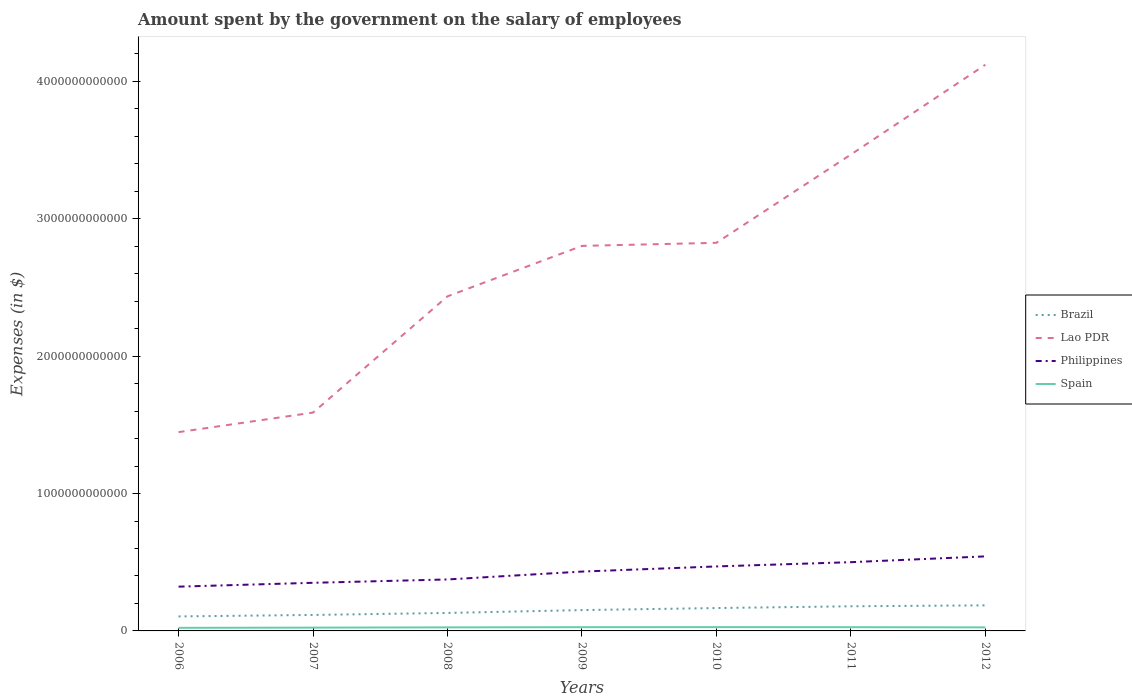How many different coloured lines are there?
Your answer should be very brief. 4. Across all years, what is the maximum amount spent on the salary of employees by the government in Brazil?
Keep it short and to the point. 1.05e+11. In which year was the amount spent on the salary of employees by the government in Spain maximum?
Offer a very short reply. 2006. What is the total amount spent on the salary of employees by the government in Spain in the graph?
Provide a short and direct response. 1.39e+09. What is the difference between the highest and the second highest amount spent on the salary of employees by the government in Brazil?
Keep it short and to the point. 8.06e+1. What is the difference between the highest and the lowest amount spent on the salary of employees by the government in Philippines?
Your response must be concise. 4. Is the amount spent on the salary of employees by the government in Brazil strictly greater than the amount spent on the salary of employees by the government in Spain over the years?
Ensure brevity in your answer.  No. What is the difference between two consecutive major ticks on the Y-axis?
Your answer should be very brief. 1.00e+12. Are the values on the major ticks of Y-axis written in scientific E-notation?
Offer a terse response. No. Where does the legend appear in the graph?
Give a very brief answer. Center right. How are the legend labels stacked?
Provide a succinct answer. Vertical. What is the title of the graph?
Keep it short and to the point. Amount spent by the government on the salary of employees. What is the label or title of the Y-axis?
Your answer should be compact. Expenses (in $). What is the Expenses (in $) of Brazil in 2006?
Your answer should be very brief. 1.05e+11. What is the Expenses (in $) of Lao PDR in 2006?
Offer a very short reply. 1.45e+12. What is the Expenses (in $) of Philippines in 2006?
Keep it short and to the point. 3.22e+11. What is the Expenses (in $) of Spain in 2006?
Your response must be concise. 2.25e+1. What is the Expenses (in $) of Brazil in 2007?
Your answer should be very brief. 1.16e+11. What is the Expenses (in $) of Lao PDR in 2007?
Make the answer very short. 1.59e+12. What is the Expenses (in $) in Philippines in 2007?
Make the answer very short. 3.50e+11. What is the Expenses (in $) in Spain in 2007?
Offer a very short reply. 2.40e+1. What is the Expenses (in $) in Brazil in 2008?
Offer a very short reply. 1.31e+11. What is the Expenses (in $) in Lao PDR in 2008?
Keep it short and to the point. 2.44e+12. What is the Expenses (in $) in Philippines in 2008?
Provide a succinct answer. 3.75e+11. What is the Expenses (in $) of Spain in 2008?
Your answer should be compact. 2.58e+1. What is the Expenses (in $) of Brazil in 2009?
Your answer should be very brief. 1.52e+11. What is the Expenses (in $) of Lao PDR in 2009?
Make the answer very short. 2.80e+12. What is the Expenses (in $) in Philippines in 2009?
Your answer should be very brief. 4.32e+11. What is the Expenses (in $) in Spain in 2009?
Keep it short and to the point. 2.71e+1. What is the Expenses (in $) in Brazil in 2010?
Offer a terse response. 1.66e+11. What is the Expenses (in $) of Lao PDR in 2010?
Your response must be concise. 2.83e+12. What is the Expenses (in $) in Philippines in 2010?
Offer a terse response. 4.69e+11. What is the Expenses (in $) of Spain in 2010?
Give a very brief answer. 2.76e+1. What is the Expenses (in $) of Brazil in 2011?
Offer a terse response. 1.79e+11. What is the Expenses (in $) of Lao PDR in 2011?
Provide a short and direct response. 3.47e+12. What is the Expenses (in $) in Philippines in 2011?
Ensure brevity in your answer.  5.00e+11. What is the Expenses (in $) of Spain in 2011?
Your answer should be compact. 2.71e+1. What is the Expenses (in $) in Brazil in 2012?
Your answer should be very brief. 1.86e+11. What is the Expenses (in $) of Lao PDR in 2012?
Ensure brevity in your answer.  4.12e+12. What is the Expenses (in $) of Philippines in 2012?
Your response must be concise. 5.43e+11. What is the Expenses (in $) of Spain in 2012?
Your answer should be compact. 2.58e+1. Across all years, what is the maximum Expenses (in $) of Brazil?
Your response must be concise. 1.86e+11. Across all years, what is the maximum Expenses (in $) in Lao PDR?
Your response must be concise. 4.12e+12. Across all years, what is the maximum Expenses (in $) in Philippines?
Ensure brevity in your answer.  5.43e+11. Across all years, what is the maximum Expenses (in $) in Spain?
Keep it short and to the point. 2.76e+1. Across all years, what is the minimum Expenses (in $) of Brazil?
Your answer should be compact. 1.05e+11. Across all years, what is the minimum Expenses (in $) of Lao PDR?
Offer a very short reply. 1.45e+12. Across all years, what is the minimum Expenses (in $) of Philippines?
Your response must be concise. 3.22e+11. Across all years, what is the minimum Expenses (in $) of Spain?
Your answer should be very brief. 2.25e+1. What is the total Expenses (in $) in Brazil in the graph?
Your answer should be compact. 1.04e+12. What is the total Expenses (in $) of Lao PDR in the graph?
Your answer should be very brief. 1.87e+13. What is the total Expenses (in $) of Philippines in the graph?
Provide a succinct answer. 2.99e+12. What is the total Expenses (in $) of Spain in the graph?
Make the answer very short. 1.80e+11. What is the difference between the Expenses (in $) in Brazil in 2006 and that in 2007?
Give a very brief answer. -1.09e+1. What is the difference between the Expenses (in $) of Lao PDR in 2006 and that in 2007?
Your answer should be very brief. -1.42e+11. What is the difference between the Expenses (in $) in Philippines in 2006 and that in 2007?
Provide a short and direct response. -2.80e+1. What is the difference between the Expenses (in $) in Spain in 2006 and that in 2007?
Ensure brevity in your answer.  -1.55e+09. What is the difference between the Expenses (in $) of Brazil in 2006 and that in 2008?
Provide a succinct answer. -2.53e+1. What is the difference between the Expenses (in $) of Lao PDR in 2006 and that in 2008?
Provide a short and direct response. -9.88e+11. What is the difference between the Expenses (in $) in Philippines in 2006 and that in 2008?
Provide a succinct answer. -5.24e+1. What is the difference between the Expenses (in $) of Spain in 2006 and that in 2008?
Offer a terse response. -3.36e+09. What is the difference between the Expenses (in $) of Brazil in 2006 and that in 2009?
Make the answer very short. -4.62e+1. What is the difference between the Expenses (in $) in Lao PDR in 2006 and that in 2009?
Offer a very short reply. -1.36e+12. What is the difference between the Expenses (in $) in Philippines in 2006 and that in 2009?
Offer a very short reply. -1.10e+11. What is the difference between the Expenses (in $) in Spain in 2006 and that in 2009?
Keep it short and to the point. -4.68e+09. What is the difference between the Expenses (in $) in Brazil in 2006 and that in 2010?
Provide a short and direct response. -6.10e+1. What is the difference between the Expenses (in $) in Lao PDR in 2006 and that in 2010?
Offer a very short reply. -1.38e+12. What is the difference between the Expenses (in $) in Philippines in 2006 and that in 2010?
Give a very brief answer. -1.47e+11. What is the difference between the Expenses (in $) in Spain in 2006 and that in 2010?
Provide a short and direct response. -5.13e+09. What is the difference between the Expenses (in $) in Brazil in 2006 and that in 2011?
Your answer should be very brief. -7.38e+1. What is the difference between the Expenses (in $) of Lao PDR in 2006 and that in 2011?
Your response must be concise. -2.02e+12. What is the difference between the Expenses (in $) of Philippines in 2006 and that in 2011?
Keep it short and to the point. -1.78e+11. What is the difference between the Expenses (in $) in Spain in 2006 and that in 2011?
Offer a very short reply. -4.67e+09. What is the difference between the Expenses (in $) of Brazil in 2006 and that in 2012?
Offer a very short reply. -8.06e+1. What is the difference between the Expenses (in $) of Lao PDR in 2006 and that in 2012?
Give a very brief answer. -2.67e+12. What is the difference between the Expenses (in $) of Philippines in 2006 and that in 2012?
Ensure brevity in your answer.  -2.20e+11. What is the difference between the Expenses (in $) in Spain in 2006 and that in 2012?
Make the answer very short. -3.29e+09. What is the difference between the Expenses (in $) of Brazil in 2007 and that in 2008?
Make the answer very short. -1.45e+1. What is the difference between the Expenses (in $) of Lao PDR in 2007 and that in 2008?
Provide a short and direct response. -8.46e+11. What is the difference between the Expenses (in $) of Philippines in 2007 and that in 2008?
Ensure brevity in your answer.  -2.44e+1. What is the difference between the Expenses (in $) in Spain in 2007 and that in 2008?
Ensure brevity in your answer.  -1.80e+09. What is the difference between the Expenses (in $) in Brazil in 2007 and that in 2009?
Your answer should be very brief. -3.53e+1. What is the difference between the Expenses (in $) of Lao PDR in 2007 and that in 2009?
Provide a succinct answer. -1.21e+12. What is the difference between the Expenses (in $) in Philippines in 2007 and that in 2009?
Provide a succinct answer. -8.17e+1. What is the difference between the Expenses (in $) of Spain in 2007 and that in 2009?
Offer a very short reply. -3.12e+09. What is the difference between the Expenses (in $) in Brazil in 2007 and that in 2010?
Ensure brevity in your answer.  -5.01e+1. What is the difference between the Expenses (in $) of Lao PDR in 2007 and that in 2010?
Your response must be concise. -1.24e+12. What is the difference between the Expenses (in $) in Philippines in 2007 and that in 2010?
Your answer should be very brief. -1.19e+11. What is the difference between the Expenses (in $) of Spain in 2007 and that in 2010?
Provide a short and direct response. -3.58e+09. What is the difference between the Expenses (in $) of Brazil in 2007 and that in 2011?
Your answer should be compact. -6.29e+1. What is the difference between the Expenses (in $) of Lao PDR in 2007 and that in 2011?
Ensure brevity in your answer.  -1.88e+12. What is the difference between the Expenses (in $) in Philippines in 2007 and that in 2011?
Ensure brevity in your answer.  -1.50e+11. What is the difference between the Expenses (in $) in Spain in 2007 and that in 2011?
Your answer should be compact. -3.12e+09. What is the difference between the Expenses (in $) in Brazil in 2007 and that in 2012?
Keep it short and to the point. -6.97e+1. What is the difference between the Expenses (in $) in Lao PDR in 2007 and that in 2012?
Provide a succinct answer. -2.53e+12. What is the difference between the Expenses (in $) in Philippines in 2007 and that in 2012?
Your answer should be very brief. -1.92e+11. What is the difference between the Expenses (in $) in Spain in 2007 and that in 2012?
Ensure brevity in your answer.  -1.74e+09. What is the difference between the Expenses (in $) in Brazil in 2008 and that in 2009?
Provide a succinct answer. -2.08e+1. What is the difference between the Expenses (in $) in Lao PDR in 2008 and that in 2009?
Make the answer very short. -3.67e+11. What is the difference between the Expenses (in $) of Philippines in 2008 and that in 2009?
Provide a succinct answer. -5.74e+1. What is the difference between the Expenses (in $) in Spain in 2008 and that in 2009?
Keep it short and to the point. -1.32e+09. What is the difference between the Expenses (in $) in Brazil in 2008 and that in 2010?
Ensure brevity in your answer.  -3.57e+1. What is the difference between the Expenses (in $) in Lao PDR in 2008 and that in 2010?
Provide a succinct answer. -3.90e+11. What is the difference between the Expenses (in $) of Philippines in 2008 and that in 2010?
Your answer should be compact. -9.47e+1. What is the difference between the Expenses (in $) in Spain in 2008 and that in 2010?
Your answer should be very brief. -1.78e+09. What is the difference between the Expenses (in $) in Brazil in 2008 and that in 2011?
Ensure brevity in your answer.  -4.84e+1. What is the difference between the Expenses (in $) in Lao PDR in 2008 and that in 2011?
Give a very brief answer. -1.03e+12. What is the difference between the Expenses (in $) of Philippines in 2008 and that in 2011?
Ensure brevity in your answer.  -1.26e+11. What is the difference between the Expenses (in $) of Spain in 2008 and that in 2011?
Your answer should be compact. -1.32e+09. What is the difference between the Expenses (in $) in Brazil in 2008 and that in 2012?
Your answer should be compact. -5.53e+1. What is the difference between the Expenses (in $) of Lao PDR in 2008 and that in 2012?
Offer a terse response. -1.69e+12. What is the difference between the Expenses (in $) of Philippines in 2008 and that in 2012?
Keep it short and to the point. -1.68e+11. What is the difference between the Expenses (in $) in Spain in 2008 and that in 2012?
Your answer should be very brief. 6.30e+07. What is the difference between the Expenses (in $) of Brazil in 2009 and that in 2010?
Provide a short and direct response. -1.48e+1. What is the difference between the Expenses (in $) of Lao PDR in 2009 and that in 2010?
Make the answer very short. -2.24e+1. What is the difference between the Expenses (in $) in Philippines in 2009 and that in 2010?
Make the answer very short. -3.74e+1. What is the difference between the Expenses (in $) in Spain in 2009 and that in 2010?
Make the answer very short. -4.54e+08. What is the difference between the Expenses (in $) in Brazil in 2009 and that in 2011?
Give a very brief answer. -2.76e+1. What is the difference between the Expenses (in $) of Lao PDR in 2009 and that in 2011?
Your answer should be very brief. -6.65e+11. What is the difference between the Expenses (in $) of Philippines in 2009 and that in 2011?
Offer a very short reply. -6.84e+1. What is the difference between the Expenses (in $) of Spain in 2009 and that in 2011?
Make the answer very short. 9.00e+06. What is the difference between the Expenses (in $) of Brazil in 2009 and that in 2012?
Keep it short and to the point. -3.44e+1. What is the difference between the Expenses (in $) in Lao PDR in 2009 and that in 2012?
Your response must be concise. -1.32e+12. What is the difference between the Expenses (in $) of Philippines in 2009 and that in 2012?
Keep it short and to the point. -1.11e+11. What is the difference between the Expenses (in $) in Spain in 2009 and that in 2012?
Make the answer very short. 1.39e+09. What is the difference between the Expenses (in $) of Brazil in 2010 and that in 2011?
Provide a succinct answer. -1.28e+1. What is the difference between the Expenses (in $) in Lao PDR in 2010 and that in 2011?
Ensure brevity in your answer.  -6.43e+11. What is the difference between the Expenses (in $) in Philippines in 2010 and that in 2011?
Provide a short and direct response. -3.10e+1. What is the difference between the Expenses (in $) in Spain in 2010 and that in 2011?
Your response must be concise. 4.63e+08. What is the difference between the Expenses (in $) of Brazil in 2010 and that in 2012?
Your answer should be compact. -1.96e+1. What is the difference between the Expenses (in $) of Lao PDR in 2010 and that in 2012?
Ensure brevity in your answer.  -1.30e+12. What is the difference between the Expenses (in $) in Philippines in 2010 and that in 2012?
Make the answer very short. -7.32e+1. What is the difference between the Expenses (in $) in Spain in 2010 and that in 2012?
Your answer should be compact. 1.84e+09. What is the difference between the Expenses (in $) in Brazil in 2011 and that in 2012?
Provide a succinct answer. -6.82e+09. What is the difference between the Expenses (in $) of Lao PDR in 2011 and that in 2012?
Provide a short and direct response. -6.54e+11. What is the difference between the Expenses (in $) of Philippines in 2011 and that in 2012?
Your response must be concise. -4.22e+1. What is the difference between the Expenses (in $) of Spain in 2011 and that in 2012?
Give a very brief answer. 1.38e+09. What is the difference between the Expenses (in $) in Brazil in 2006 and the Expenses (in $) in Lao PDR in 2007?
Your answer should be compact. -1.48e+12. What is the difference between the Expenses (in $) of Brazil in 2006 and the Expenses (in $) of Philippines in 2007?
Your answer should be compact. -2.45e+11. What is the difference between the Expenses (in $) of Brazil in 2006 and the Expenses (in $) of Spain in 2007?
Keep it short and to the point. 8.15e+1. What is the difference between the Expenses (in $) of Lao PDR in 2006 and the Expenses (in $) of Philippines in 2007?
Your answer should be compact. 1.10e+12. What is the difference between the Expenses (in $) in Lao PDR in 2006 and the Expenses (in $) in Spain in 2007?
Make the answer very short. 1.42e+12. What is the difference between the Expenses (in $) in Philippines in 2006 and the Expenses (in $) in Spain in 2007?
Provide a short and direct response. 2.98e+11. What is the difference between the Expenses (in $) in Brazil in 2006 and the Expenses (in $) in Lao PDR in 2008?
Your answer should be compact. -2.33e+12. What is the difference between the Expenses (in $) in Brazil in 2006 and the Expenses (in $) in Philippines in 2008?
Ensure brevity in your answer.  -2.69e+11. What is the difference between the Expenses (in $) in Brazil in 2006 and the Expenses (in $) in Spain in 2008?
Keep it short and to the point. 7.97e+1. What is the difference between the Expenses (in $) of Lao PDR in 2006 and the Expenses (in $) of Philippines in 2008?
Make the answer very short. 1.07e+12. What is the difference between the Expenses (in $) in Lao PDR in 2006 and the Expenses (in $) in Spain in 2008?
Your answer should be compact. 1.42e+12. What is the difference between the Expenses (in $) in Philippines in 2006 and the Expenses (in $) in Spain in 2008?
Ensure brevity in your answer.  2.96e+11. What is the difference between the Expenses (in $) of Brazil in 2006 and the Expenses (in $) of Lao PDR in 2009?
Keep it short and to the point. -2.70e+12. What is the difference between the Expenses (in $) in Brazil in 2006 and the Expenses (in $) in Philippines in 2009?
Your response must be concise. -3.27e+11. What is the difference between the Expenses (in $) in Brazil in 2006 and the Expenses (in $) in Spain in 2009?
Provide a succinct answer. 7.83e+1. What is the difference between the Expenses (in $) in Lao PDR in 2006 and the Expenses (in $) in Philippines in 2009?
Ensure brevity in your answer.  1.02e+12. What is the difference between the Expenses (in $) of Lao PDR in 2006 and the Expenses (in $) of Spain in 2009?
Give a very brief answer. 1.42e+12. What is the difference between the Expenses (in $) in Philippines in 2006 and the Expenses (in $) in Spain in 2009?
Your response must be concise. 2.95e+11. What is the difference between the Expenses (in $) of Brazil in 2006 and the Expenses (in $) of Lao PDR in 2010?
Provide a succinct answer. -2.72e+12. What is the difference between the Expenses (in $) of Brazil in 2006 and the Expenses (in $) of Philippines in 2010?
Keep it short and to the point. -3.64e+11. What is the difference between the Expenses (in $) of Brazil in 2006 and the Expenses (in $) of Spain in 2010?
Offer a very short reply. 7.79e+1. What is the difference between the Expenses (in $) in Lao PDR in 2006 and the Expenses (in $) in Philippines in 2010?
Your answer should be compact. 9.78e+11. What is the difference between the Expenses (in $) of Lao PDR in 2006 and the Expenses (in $) of Spain in 2010?
Offer a terse response. 1.42e+12. What is the difference between the Expenses (in $) in Philippines in 2006 and the Expenses (in $) in Spain in 2010?
Your answer should be very brief. 2.95e+11. What is the difference between the Expenses (in $) of Brazil in 2006 and the Expenses (in $) of Lao PDR in 2011?
Your answer should be very brief. -3.36e+12. What is the difference between the Expenses (in $) of Brazil in 2006 and the Expenses (in $) of Philippines in 2011?
Offer a terse response. -3.95e+11. What is the difference between the Expenses (in $) in Brazil in 2006 and the Expenses (in $) in Spain in 2011?
Offer a very short reply. 7.84e+1. What is the difference between the Expenses (in $) of Lao PDR in 2006 and the Expenses (in $) of Philippines in 2011?
Ensure brevity in your answer.  9.47e+11. What is the difference between the Expenses (in $) of Lao PDR in 2006 and the Expenses (in $) of Spain in 2011?
Your response must be concise. 1.42e+12. What is the difference between the Expenses (in $) of Philippines in 2006 and the Expenses (in $) of Spain in 2011?
Your response must be concise. 2.95e+11. What is the difference between the Expenses (in $) of Brazil in 2006 and the Expenses (in $) of Lao PDR in 2012?
Keep it short and to the point. -4.02e+12. What is the difference between the Expenses (in $) in Brazil in 2006 and the Expenses (in $) in Philippines in 2012?
Keep it short and to the point. -4.37e+11. What is the difference between the Expenses (in $) in Brazil in 2006 and the Expenses (in $) in Spain in 2012?
Your answer should be very brief. 7.97e+1. What is the difference between the Expenses (in $) in Lao PDR in 2006 and the Expenses (in $) in Philippines in 2012?
Make the answer very short. 9.04e+11. What is the difference between the Expenses (in $) in Lao PDR in 2006 and the Expenses (in $) in Spain in 2012?
Offer a terse response. 1.42e+12. What is the difference between the Expenses (in $) of Philippines in 2006 and the Expenses (in $) of Spain in 2012?
Your answer should be compact. 2.97e+11. What is the difference between the Expenses (in $) in Brazil in 2007 and the Expenses (in $) in Lao PDR in 2008?
Offer a very short reply. -2.32e+12. What is the difference between the Expenses (in $) of Brazil in 2007 and the Expenses (in $) of Philippines in 2008?
Offer a very short reply. -2.58e+11. What is the difference between the Expenses (in $) in Brazil in 2007 and the Expenses (in $) in Spain in 2008?
Offer a terse response. 9.05e+1. What is the difference between the Expenses (in $) of Lao PDR in 2007 and the Expenses (in $) of Philippines in 2008?
Give a very brief answer. 1.21e+12. What is the difference between the Expenses (in $) in Lao PDR in 2007 and the Expenses (in $) in Spain in 2008?
Offer a terse response. 1.56e+12. What is the difference between the Expenses (in $) of Philippines in 2007 and the Expenses (in $) of Spain in 2008?
Give a very brief answer. 3.24e+11. What is the difference between the Expenses (in $) of Brazil in 2007 and the Expenses (in $) of Lao PDR in 2009?
Your response must be concise. -2.69e+12. What is the difference between the Expenses (in $) in Brazil in 2007 and the Expenses (in $) in Philippines in 2009?
Offer a very short reply. -3.16e+11. What is the difference between the Expenses (in $) of Brazil in 2007 and the Expenses (in $) of Spain in 2009?
Keep it short and to the point. 8.92e+1. What is the difference between the Expenses (in $) in Lao PDR in 2007 and the Expenses (in $) in Philippines in 2009?
Ensure brevity in your answer.  1.16e+12. What is the difference between the Expenses (in $) of Lao PDR in 2007 and the Expenses (in $) of Spain in 2009?
Offer a terse response. 1.56e+12. What is the difference between the Expenses (in $) in Philippines in 2007 and the Expenses (in $) in Spain in 2009?
Offer a terse response. 3.23e+11. What is the difference between the Expenses (in $) in Brazil in 2007 and the Expenses (in $) in Lao PDR in 2010?
Provide a short and direct response. -2.71e+12. What is the difference between the Expenses (in $) of Brazil in 2007 and the Expenses (in $) of Philippines in 2010?
Provide a succinct answer. -3.53e+11. What is the difference between the Expenses (in $) of Brazil in 2007 and the Expenses (in $) of Spain in 2010?
Your answer should be compact. 8.88e+1. What is the difference between the Expenses (in $) in Lao PDR in 2007 and the Expenses (in $) in Philippines in 2010?
Your response must be concise. 1.12e+12. What is the difference between the Expenses (in $) of Lao PDR in 2007 and the Expenses (in $) of Spain in 2010?
Your answer should be compact. 1.56e+12. What is the difference between the Expenses (in $) in Philippines in 2007 and the Expenses (in $) in Spain in 2010?
Offer a very short reply. 3.23e+11. What is the difference between the Expenses (in $) in Brazil in 2007 and the Expenses (in $) in Lao PDR in 2011?
Offer a terse response. -3.35e+12. What is the difference between the Expenses (in $) of Brazil in 2007 and the Expenses (in $) of Philippines in 2011?
Provide a succinct answer. -3.84e+11. What is the difference between the Expenses (in $) in Brazil in 2007 and the Expenses (in $) in Spain in 2011?
Provide a succinct answer. 8.92e+1. What is the difference between the Expenses (in $) in Lao PDR in 2007 and the Expenses (in $) in Philippines in 2011?
Keep it short and to the point. 1.09e+12. What is the difference between the Expenses (in $) in Lao PDR in 2007 and the Expenses (in $) in Spain in 2011?
Ensure brevity in your answer.  1.56e+12. What is the difference between the Expenses (in $) of Philippines in 2007 and the Expenses (in $) of Spain in 2011?
Offer a terse response. 3.23e+11. What is the difference between the Expenses (in $) in Brazil in 2007 and the Expenses (in $) in Lao PDR in 2012?
Provide a succinct answer. -4.01e+12. What is the difference between the Expenses (in $) in Brazil in 2007 and the Expenses (in $) in Philippines in 2012?
Your answer should be compact. -4.26e+11. What is the difference between the Expenses (in $) in Brazil in 2007 and the Expenses (in $) in Spain in 2012?
Offer a very short reply. 9.06e+1. What is the difference between the Expenses (in $) of Lao PDR in 2007 and the Expenses (in $) of Philippines in 2012?
Make the answer very short. 1.05e+12. What is the difference between the Expenses (in $) in Lao PDR in 2007 and the Expenses (in $) in Spain in 2012?
Your answer should be compact. 1.56e+12. What is the difference between the Expenses (in $) in Philippines in 2007 and the Expenses (in $) in Spain in 2012?
Your response must be concise. 3.25e+11. What is the difference between the Expenses (in $) of Brazil in 2008 and the Expenses (in $) of Lao PDR in 2009?
Your response must be concise. -2.67e+12. What is the difference between the Expenses (in $) of Brazil in 2008 and the Expenses (in $) of Philippines in 2009?
Provide a succinct answer. -3.01e+11. What is the difference between the Expenses (in $) in Brazil in 2008 and the Expenses (in $) in Spain in 2009?
Your answer should be compact. 1.04e+11. What is the difference between the Expenses (in $) of Lao PDR in 2008 and the Expenses (in $) of Philippines in 2009?
Give a very brief answer. 2.00e+12. What is the difference between the Expenses (in $) of Lao PDR in 2008 and the Expenses (in $) of Spain in 2009?
Keep it short and to the point. 2.41e+12. What is the difference between the Expenses (in $) of Philippines in 2008 and the Expenses (in $) of Spain in 2009?
Provide a short and direct response. 3.48e+11. What is the difference between the Expenses (in $) of Brazil in 2008 and the Expenses (in $) of Lao PDR in 2010?
Offer a very short reply. -2.69e+12. What is the difference between the Expenses (in $) in Brazil in 2008 and the Expenses (in $) in Philippines in 2010?
Keep it short and to the point. -3.39e+11. What is the difference between the Expenses (in $) of Brazil in 2008 and the Expenses (in $) of Spain in 2010?
Make the answer very short. 1.03e+11. What is the difference between the Expenses (in $) of Lao PDR in 2008 and the Expenses (in $) of Philippines in 2010?
Make the answer very short. 1.97e+12. What is the difference between the Expenses (in $) of Lao PDR in 2008 and the Expenses (in $) of Spain in 2010?
Your response must be concise. 2.41e+12. What is the difference between the Expenses (in $) of Philippines in 2008 and the Expenses (in $) of Spain in 2010?
Your answer should be compact. 3.47e+11. What is the difference between the Expenses (in $) of Brazil in 2008 and the Expenses (in $) of Lao PDR in 2011?
Provide a succinct answer. -3.34e+12. What is the difference between the Expenses (in $) in Brazil in 2008 and the Expenses (in $) in Philippines in 2011?
Give a very brief answer. -3.70e+11. What is the difference between the Expenses (in $) in Brazil in 2008 and the Expenses (in $) in Spain in 2011?
Provide a short and direct response. 1.04e+11. What is the difference between the Expenses (in $) of Lao PDR in 2008 and the Expenses (in $) of Philippines in 2011?
Provide a succinct answer. 1.94e+12. What is the difference between the Expenses (in $) of Lao PDR in 2008 and the Expenses (in $) of Spain in 2011?
Provide a short and direct response. 2.41e+12. What is the difference between the Expenses (in $) in Philippines in 2008 and the Expenses (in $) in Spain in 2011?
Make the answer very short. 3.48e+11. What is the difference between the Expenses (in $) in Brazil in 2008 and the Expenses (in $) in Lao PDR in 2012?
Offer a very short reply. -3.99e+12. What is the difference between the Expenses (in $) of Brazil in 2008 and the Expenses (in $) of Philippines in 2012?
Keep it short and to the point. -4.12e+11. What is the difference between the Expenses (in $) in Brazil in 2008 and the Expenses (in $) in Spain in 2012?
Keep it short and to the point. 1.05e+11. What is the difference between the Expenses (in $) in Lao PDR in 2008 and the Expenses (in $) in Philippines in 2012?
Keep it short and to the point. 1.89e+12. What is the difference between the Expenses (in $) of Lao PDR in 2008 and the Expenses (in $) of Spain in 2012?
Provide a short and direct response. 2.41e+12. What is the difference between the Expenses (in $) of Philippines in 2008 and the Expenses (in $) of Spain in 2012?
Provide a succinct answer. 3.49e+11. What is the difference between the Expenses (in $) in Brazil in 2009 and the Expenses (in $) in Lao PDR in 2010?
Provide a succinct answer. -2.67e+12. What is the difference between the Expenses (in $) in Brazil in 2009 and the Expenses (in $) in Philippines in 2010?
Your answer should be very brief. -3.18e+11. What is the difference between the Expenses (in $) of Brazil in 2009 and the Expenses (in $) of Spain in 2010?
Keep it short and to the point. 1.24e+11. What is the difference between the Expenses (in $) of Lao PDR in 2009 and the Expenses (in $) of Philippines in 2010?
Provide a succinct answer. 2.33e+12. What is the difference between the Expenses (in $) in Lao PDR in 2009 and the Expenses (in $) in Spain in 2010?
Your response must be concise. 2.78e+12. What is the difference between the Expenses (in $) of Philippines in 2009 and the Expenses (in $) of Spain in 2010?
Offer a very short reply. 4.04e+11. What is the difference between the Expenses (in $) in Brazil in 2009 and the Expenses (in $) in Lao PDR in 2011?
Provide a succinct answer. -3.32e+12. What is the difference between the Expenses (in $) in Brazil in 2009 and the Expenses (in $) in Philippines in 2011?
Ensure brevity in your answer.  -3.49e+11. What is the difference between the Expenses (in $) of Brazil in 2009 and the Expenses (in $) of Spain in 2011?
Your response must be concise. 1.25e+11. What is the difference between the Expenses (in $) in Lao PDR in 2009 and the Expenses (in $) in Philippines in 2011?
Your response must be concise. 2.30e+12. What is the difference between the Expenses (in $) of Lao PDR in 2009 and the Expenses (in $) of Spain in 2011?
Provide a short and direct response. 2.78e+12. What is the difference between the Expenses (in $) in Philippines in 2009 and the Expenses (in $) in Spain in 2011?
Offer a very short reply. 4.05e+11. What is the difference between the Expenses (in $) in Brazil in 2009 and the Expenses (in $) in Lao PDR in 2012?
Your response must be concise. -3.97e+12. What is the difference between the Expenses (in $) of Brazil in 2009 and the Expenses (in $) of Philippines in 2012?
Your response must be concise. -3.91e+11. What is the difference between the Expenses (in $) of Brazil in 2009 and the Expenses (in $) of Spain in 2012?
Keep it short and to the point. 1.26e+11. What is the difference between the Expenses (in $) in Lao PDR in 2009 and the Expenses (in $) in Philippines in 2012?
Offer a terse response. 2.26e+12. What is the difference between the Expenses (in $) in Lao PDR in 2009 and the Expenses (in $) in Spain in 2012?
Your response must be concise. 2.78e+12. What is the difference between the Expenses (in $) of Philippines in 2009 and the Expenses (in $) of Spain in 2012?
Your answer should be compact. 4.06e+11. What is the difference between the Expenses (in $) in Brazil in 2010 and the Expenses (in $) in Lao PDR in 2011?
Offer a very short reply. -3.30e+12. What is the difference between the Expenses (in $) in Brazil in 2010 and the Expenses (in $) in Philippines in 2011?
Make the answer very short. -3.34e+11. What is the difference between the Expenses (in $) of Brazil in 2010 and the Expenses (in $) of Spain in 2011?
Your response must be concise. 1.39e+11. What is the difference between the Expenses (in $) of Lao PDR in 2010 and the Expenses (in $) of Philippines in 2011?
Offer a terse response. 2.32e+12. What is the difference between the Expenses (in $) in Lao PDR in 2010 and the Expenses (in $) in Spain in 2011?
Your answer should be compact. 2.80e+12. What is the difference between the Expenses (in $) in Philippines in 2010 and the Expenses (in $) in Spain in 2011?
Keep it short and to the point. 4.42e+11. What is the difference between the Expenses (in $) of Brazil in 2010 and the Expenses (in $) of Lao PDR in 2012?
Provide a succinct answer. -3.95e+12. What is the difference between the Expenses (in $) in Brazil in 2010 and the Expenses (in $) in Philippines in 2012?
Give a very brief answer. -3.76e+11. What is the difference between the Expenses (in $) in Brazil in 2010 and the Expenses (in $) in Spain in 2012?
Your response must be concise. 1.41e+11. What is the difference between the Expenses (in $) in Lao PDR in 2010 and the Expenses (in $) in Philippines in 2012?
Your answer should be compact. 2.28e+12. What is the difference between the Expenses (in $) of Lao PDR in 2010 and the Expenses (in $) of Spain in 2012?
Keep it short and to the point. 2.80e+12. What is the difference between the Expenses (in $) in Philippines in 2010 and the Expenses (in $) in Spain in 2012?
Your answer should be compact. 4.44e+11. What is the difference between the Expenses (in $) of Brazil in 2011 and the Expenses (in $) of Lao PDR in 2012?
Provide a short and direct response. -3.94e+12. What is the difference between the Expenses (in $) in Brazil in 2011 and the Expenses (in $) in Philippines in 2012?
Your answer should be compact. -3.63e+11. What is the difference between the Expenses (in $) of Brazil in 2011 and the Expenses (in $) of Spain in 2012?
Your response must be concise. 1.54e+11. What is the difference between the Expenses (in $) in Lao PDR in 2011 and the Expenses (in $) in Philippines in 2012?
Ensure brevity in your answer.  2.93e+12. What is the difference between the Expenses (in $) in Lao PDR in 2011 and the Expenses (in $) in Spain in 2012?
Provide a succinct answer. 3.44e+12. What is the difference between the Expenses (in $) in Philippines in 2011 and the Expenses (in $) in Spain in 2012?
Offer a very short reply. 4.75e+11. What is the average Expenses (in $) in Brazil per year?
Keep it short and to the point. 1.48e+11. What is the average Expenses (in $) of Lao PDR per year?
Offer a terse response. 2.67e+12. What is the average Expenses (in $) of Philippines per year?
Your answer should be very brief. 4.27e+11. What is the average Expenses (in $) in Spain per year?
Give a very brief answer. 2.57e+1. In the year 2006, what is the difference between the Expenses (in $) of Brazil and Expenses (in $) of Lao PDR?
Offer a terse response. -1.34e+12. In the year 2006, what is the difference between the Expenses (in $) in Brazil and Expenses (in $) in Philippines?
Provide a succinct answer. -2.17e+11. In the year 2006, what is the difference between the Expenses (in $) of Brazil and Expenses (in $) of Spain?
Your answer should be compact. 8.30e+1. In the year 2006, what is the difference between the Expenses (in $) in Lao PDR and Expenses (in $) in Philippines?
Your answer should be very brief. 1.12e+12. In the year 2006, what is the difference between the Expenses (in $) in Lao PDR and Expenses (in $) in Spain?
Keep it short and to the point. 1.42e+12. In the year 2006, what is the difference between the Expenses (in $) of Philippines and Expenses (in $) of Spain?
Keep it short and to the point. 3.00e+11. In the year 2007, what is the difference between the Expenses (in $) of Brazil and Expenses (in $) of Lao PDR?
Your answer should be compact. -1.47e+12. In the year 2007, what is the difference between the Expenses (in $) in Brazil and Expenses (in $) in Philippines?
Your answer should be compact. -2.34e+11. In the year 2007, what is the difference between the Expenses (in $) of Brazil and Expenses (in $) of Spain?
Give a very brief answer. 9.23e+1. In the year 2007, what is the difference between the Expenses (in $) of Lao PDR and Expenses (in $) of Philippines?
Make the answer very short. 1.24e+12. In the year 2007, what is the difference between the Expenses (in $) of Lao PDR and Expenses (in $) of Spain?
Offer a terse response. 1.57e+12. In the year 2007, what is the difference between the Expenses (in $) of Philippines and Expenses (in $) of Spain?
Ensure brevity in your answer.  3.26e+11. In the year 2008, what is the difference between the Expenses (in $) of Brazil and Expenses (in $) of Lao PDR?
Your answer should be compact. -2.30e+12. In the year 2008, what is the difference between the Expenses (in $) of Brazil and Expenses (in $) of Philippines?
Offer a terse response. -2.44e+11. In the year 2008, what is the difference between the Expenses (in $) of Brazil and Expenses (in $) of Spain?
Offer a very short reply. 1.05e+11. In the year 2008, what is the difference between the Expenses (in $) in Lao PDR and Expenses (in $) in Philippines?
Offer a very short reply. 2.06e+12. In the year 2008, what is the difference between the Expenses (in $) in Lao PDR and Expenses (in $) in Spain?
Give a very brief answer. 2.41e+12. In the year 2008, what is the difference between the Expenses (in $) of Philippines and Expenses (in $) of Spain?
Give a very brief answer. 3.49e+11. In the year 2009, what is the difference between the Expenses (in $) in Brazil and Expenses (in $) in Lao PDR?
Provide a succinct answer. -2.65e+12. In the year 2009, what is the difference between the Expenses (in $) in Brazil and Expenses (in $) in Philippines?
Provide a short and direct response. -2.80e+11. In the year 2009, what is the difference between the Expenses (in $) of Brazil and Expenses (in $) of Spain?
Your response must be concise. 1.25e+11. In the year 2009, what is the difference between the Expenses (in $) in Lao PDR and Expenses (in $) in Philippines?
Give a very brief answer. 2.37e+12. In the year 2009, what is the difference between the Expenses (in $) of Lao PDR and Expenses (in $) of Spain?
Give a very brief answer. 2.78e+12. In the year 2009, what is the difference between the Expenses (in $) of Philippines and Expenses (in $) of Spain?
Provide a short and direct response. 4.05e+11. In the year 2010, what is the difference between the Expenses (in $) in Brazil and Expenses (in $) in Lao PDR?
Give a very brief answer. -2.66e+12. In the year 2010, what is the difference between the Expenses (in $) in Brazil and Expenses (in $) in Philippines?
Provide a succinct answer. -3.03e+11. In the year 2010, what is the difference between the Expenses (in $) of Brazil and Expenses (in $) of Spain?
Ensure brevity in your answer.  1.39e+11. In the year 2010, what is the difference between the Expenses (in $) of Lao PDR and Expenses (in $) of Philippines?
Offer a very short reply. 2.36e+12. In the year 2010, what is the difference between the Expenses (in $) in Lao PDR and Expenses (in $) in Spain?
Ensure brevity in your answer.  2.80e+12. In the year 2010, what is the difference between the Expenses (in $) in Philippines and Expenses (in $) in Spain?
Your answer should be compact. 4.42e+11. In the year 2011, what is the difference between the Expenses (in $) in Brazil and Expenses (in $) in Lao PDR?
Give a very brief answer. -3.29e+12. In the year 2011, what is the difference between the Expenses (in $) of Brazil and Expenses (in $) of Philippines?
Offer a very short reply. -3.21e+11. In the year 2011, what is the difference between the Expenses (in $) of Brazil and Expenses (in $) of Spain?
Make the answer very short. 1.52e+11. In the year 2011, what is the difference between the Expenses (in $) in Lao PDR and Expenses (in $) in Philippines?
Ensure brevity in your answer.  2.97e+12. In the year 2011, what is the difference between the Expenses (in $) in Lao PDR and Expenses (in $) in Spain?
Offer a terse response. 3.44e+12. In the year 2011, what is the difference between the Expenses (in $) in Philippines and Expenses (in $) in Spain?
Keep it short and to the point. 4.73e+11. In the year 2012, what is the difference between the Expenses (in $) in Brazil and Expenses (in $) in Lao PDR?
Provide a short and direct response. -3.94e+12. In the year 2012, what is the difference between the Expenses (in $) of Brazil and Expenses (in $) of Philippines?
Provide a succinct answer. -3.57e+11. In the year 2012, what is the difference between the Expenses (in $) in Brazil and Expenses (in $) in Spain?
Make the answer very short. 1.60e+11. In the year 2012, what is the difference between the Expenses (in $) in Lao PDR and Expenses (in $) in Philippines?
Ensure brevity in your answer.  3.58e+12. In the year 2012, what is the difference between the Expenses (in $) of Lao PDR and Expenses (in $) of Spain?
Give a very brief answer. 4.10e+12. In the year 2012, what is the difference between the Expenses (in $) of Philippines and Expenses (in $) of Spain?
Offer a terse response. 5.17e+11. What is the ratio of the Expenses (in $) of Brazil in 2006 to that in 2007?
Make the answer very short. 0.91. What is the ratio of the Expenses (in $) in Lao PDR in 2006 to that in 2007?
Provide a short and direct response. 0.91. What is the ratio of the Expenses (in $) in Spain in 2006 to that in 2007?
Your answer should be very brief. 0.94. What is the ratio of the Expenses (in $) in Brazil in 2006 to that in 2008?
Offer a very short reply. 0.81. What is the ratio of the Expenses (in $) of Lao PDR in 2006 to that in 2008?
Your answer should be very brief. 0.59. What is the ratio of the Expenses (in $) in Philippines in 2006 to that in 2008?
Provide a short and direct response. 0.86. What is the ratio of the Expenses (in $) in Spain in 2006 to that in 2008?
Provide a succinct answer. 0.87. What is the ratio of the Expenses (in $) of Brazil in 2006 to that in 2009?
Provide a succinct answer. 0.7. What is the ratio of the Expenses (in $) in Lao PDR in 2006 to that in 2009?
Provide a short and direct response. 0.52. What is the ratio of the Expenses (in $) of Philippines in 2006 to that in 2009?
Your answer should be compact. 0.75. What is the ratio of the Expenses (in $) of Spain in 2006 to that in 2009?
Your response must be concise. 0.83. What is the ratio of the Expenses (in $) of Brazil in 2006 to that in 2010?
Give a very brief answer. 0.63. What is the ratio of the Expenses (in $) in Lao PDR in 2006 to that in 2010?
Ensure brevity in your answer.  0.51. What is the ratio of the Expenses (in $) in Philippines in 2006 to that in 2010?
Give a very brief answer. 0.69. What is the ratio of the Expenses (in $) in Spain in 2006 to that in 2010?
Your response must be concise. 0.81. What is the ratio of the Expenses (in $) of Brazil in 2006 to that in 2011?
Your answer should be very brief. 0.59. What is the ratio of the Expenses (in $) of Lao PDR in 2006 to that in 2011?
Provide a succinct answer. 0.42. What is the ratio of the Expenses (in $) of Philippines in 2006 to that in 2011?
Offer a very short reply. 0.64. What is the ratio of the Expenses (in $) of Spain in 2006 to that in 2011?
Your response must be concise. 0.83. What is the ratio of the Expenses (in $) in Brazil in 2006 to that in 2012?
Offer a very short reply. 0.57. What is the ratio of the Expenses (in $) in Lao PDR in 2006 to that in 2012?
Your answer should be very brief. 0.35. What is the ratio of the Expenses (in $) in Philippines in 2006 to that in 2012?
Make the answer very short. 0.59. What is the ratio of the Expenses (in $) of Spain in 2006 to that in 2012?
Your response must be concise. 0.87. What is the ratio of the Expenses (in $) in Brazil in 2007 to that in 2008?
Provide a succinct answer. 0.89. What is the ratio of the Expenses (in $) in Lao PDR in 2007 to that in 2008?
Ensure brevity in your answer.  0.65. What is the ratio of the Expenses (in $) of Philippines in 2007 to that in 2008?
Your answer should be very brief. 0.94. What is the ratio of the Expenses (in $) of Spain in 2007 to that in 2008?
Provide a short and direct response. 0.93. What is the ratio of the Expenses (in $) of Brazil in 2007 to that in 2009?
Provide a short and direct response. 0.77. What is the ratio of the Expenses (in $) of Lao PDR in 2007 to that in 2009?
Ensure brevity in your answer.  0.57. What is the ratio of the Expenses (in $) of Philippines in 2007 to that in 2009?
Offer a terse response. 0.81. What is the ratio of the Expenses (in $) of Spain in 2007 to that in 2009?
Offer a terse response. 0.88. What is the ratio of the Expenses (in $) of Brazil in 2007 to that in 2010?
Your answer should be very brief. 0.7. What is the ratio of the Expenses (in $) in Lao PDR in 2007 to that in 2010?
Provide a short and direct response. 0.56. What is the ratio of the Expenses (in $) in Philippines in 2007 to that in 2010?
Provide a short and direct response. 0.75. What is the ratio of the Expenses (in $) in Spain in 2007 to that in 2010?
Provide a short and direct response. 0.87. What is the ratio of the Expenses (in $) of Brazil in 2007 to that in 2011?
Ensure brevity in your answer.  0.65. What is the ratio of the Expenses (in $) in Lao PDR in 2007 to that in 2011?
Your answer should be very brief. 0.46. What is the ratio of the Expenses (in $) of Philippines in 2007 to that in 2011?
Keep it short and to the point. 0.7. What is the ratio of the Expenses (in $) of Spain in 2007 to that in 2011?
Your answer should be very brief. 0.89. What is the ratio of the Expenses (in $) in Brazil in 2007 to that in 2012?
Your answer should be very brief. 0.63. What is the ratio of the Expenses (in $) in Lao PDR in 2007 to that in 2012?
Your response must be concise. 0.39. What is the ratio of the Expenses (in $) in Philippines in 2007 to that in 2012?
Offer a very short reply. 0.65. What is the ratio of the Expenses (in $) of Spain in 2007 to that in 2012?
Your answer should be very brief. 0.93. What is the ratio of the Expenses (in $) in Brazil in 2008 to that in 2009?
Give a very brief answer. 0.86. What is the ratio of the Expenses (in $) in Lao PDR in 2008 to that in 2009?
Offer a very short reply. 0.87. What is the ratio of the Expenses (in $) of Philippines in 2008 to that in 2009?
Offer a very short reply. 0.87. What is the ratio of the Expenses (in $) of Spain in 2008 to that in 2009?
Offer a very short reply. 0.95. What is the ratio of the Expenses (in $) in Brazil in 2008 to that in 2010?
Your answer should be compact. 0.79. What is the ratio of the Expenses (in $) in Lao PDR in 2008 to that in 2010?
Provide a succinct answer. 0.86. What is the ratio of the Expenses (in $) in Philippines in 2008 to that in 2010?
Keep it short and to the point. 0.8. What is the ratio of the Expenses (in $) of Spain in 2008 to that in 2010?
Your answer should be compact. 0.94. What is the ratio of the Expenses (in $) of Brazil in 2008 to that in 2011?
Offer a very short reply. 0.73. What is the ratio of the Expenses (in $) in Lao PDR in 2008 to that in 2011?
Your answer should be compact. 0.7. What is the ratio of the Expenses (in $) of Philippines in 2008 to that in 2011?
Offer a very short reply. 0.75. What is the ratio of the Expenses (in $) of Spain in 2008 to that in 2011?
Keep it short and to the point. 0.95. What is the ratio of the Expenses (in $) in Brazil in 2008 to that in 2012?
Keep it short and to the point. 0.7. What is the ratio of the Expenses (in $) in Lao PDR in 2008 to that in 2012?
Offer a very short reply. 0.59. What is the ratio of the Expenses (in $) of Philippines in 2008 to that in 2012?
Provide a short and direct response. 0.69. What is the ratio of the Expenses (in $) of Spain in 2008 to that in 2012?
Offer a terse response. 1. What is the ratio of the Expenses (in $) in Brazil in 2009 to that in 2010?
Provide a short and direct response. 0.91. What is the ratio of the Expenses (in $) in Philippines in 2009 to that in 2010?
Your response must be concise. 0.92. What is the ratio of the Expenses (in $) of Spain in 2009 to that in 2010?
Your response must be concise. 0.98. What is the ratio of the Expenses (in $) in Brazil in 2009 to that in 2011?
Provide a short and direct response. 0.85. What is the ratio of the Expenses (in $) in Lao PDR in 2009 to that in 2011?
Your response must be concise. 0.81. What is the ratio of the Expenses (in $) in Philippines in 2009 to that in 2011?
Offer a terse response. 0.86. What is the ratio of the Expenses (in $) of Spain in 2009 to that in 2011?
Provide a succinct answer. 1. What is the ratio of the Expenses (in $) of Brazil in 2009 to that in 2012?
Offer a terse response. 0.81. What is the ratio of the Expenses (in $) in Lao PDR in 2009 to that in 2012?
Ensure brevity in your answer.  0.68. What is the ratio of the Expenses (in $) of Philippines in 2009 to that in 2012?
Your answer should be compact. 0.8. What is the ratio of the Expenses (in $) in Spain in 2009 to that in 2012?
Your response must be concise. 1.05. What is the ratio of the Expenses (in $) in Brazil in 2010 to that in 2011?
Give a very brief answer. 0.93. What is the ratio of the Expenses (in $) of Lao PDR in 2010 to that in 2011?
Your response must be concise. 0.81. What is the ratio of the Expenses (in $) of Philippines in 2010 to that in 2011?
Offer a very short reply. 0.94. What is the ratio of the Expenses (in $) of Spain in 2010 to that in 2011?
Make the answer very short. 1.02. What is the ratio of the Expenses (in $) in Brazil in 2010 to that in 2012?
Ensure brevity in your answer.  0.89. What is the ratio of the Expenses (in $) in Lao PDR in 2010 to that in 2012?
Make the answer very short. 0.69. What is the ratio of the Expenses (in $) of Philippines in 2010 to that in 2012?
Ensure brevity in your answer.  0.86. What is the ratio of the Expenses (in $) in Spain in 2010 to that in 2012?
Make the answer very short. 1.07. What is the ratio of the Expenses (in $) of Brazil in 2011 to that in 2012?
Offer a very short reply. 0.96. What is the ratio of the Expenses (in $) in Lao PDR in 2011 to that in 2012?
Offer a very short reply. 0.84. What is the ratio of the Expenses (in $) in Philippines in 2011 to that in 2012?
Provide a succinct answer. 0.92. What is the ratio of the Expenses (in $) of Spain in 2011 to that in 2012?
Ensure brevity in your answer.  1.05. What is the difference between the highest and the second highest Expenses (in $) in Brazil?
Your answer should be very brief. 6.82e+09. What is the difference between the highest and the second highest Expenses (in $) in Lao PDR?
Offer a terse response. 6.54e+11. What is the difference between the highest and the second highest Expenses (in $) of Philippines?
Offer a terse response. 4.22e+1. What is the difference between the highest and the second highest Expenses (in $) of Spain?
Offer a terse response. 4.54e+08. What is the difference between the highest and the lowest Expenses (in $) of Brazil?
Give a very brief answer. 8.06e+1. What is the difference between the highest and the lowest Expenses (in $) of Lao PDR?
Make the answer very short. 2.67e+12. What is the difference between the highest and the lowest Expenses (in $) of Philippines?
Ensure brevity in your answer.  2.20e+11. What is the difference between the highest and the lowest Expenses (in $) in Spain?
Your answer should be very brief. 5.13e+09. 